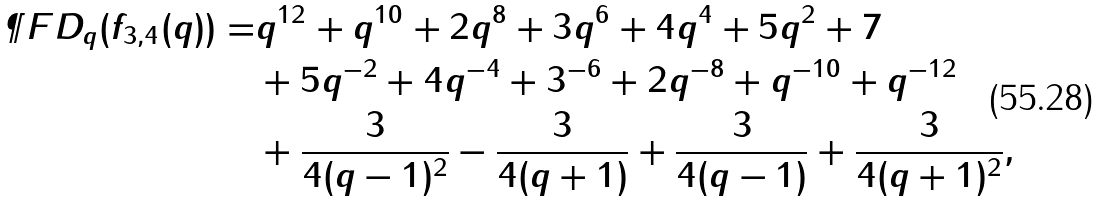Convert formula to latex. <formula><loc_0><loc_0><loc_500><loc_500>\P F D _ { q } ( f _ { 3 , 4 } ( q ) ) = & q ^ { 1 2 } + q ^ { 1 0 } + 2 q ^ { 8 } + 3 q ^ { 6 } + 4 q ^ { 4 } + 5 q ^ { 2 } + 7 \\ & + 5 q ^ { - 2 } + 4 q ^ { - 4 } + 3 ^ { - 6 } + 2 q ^ { - 8 } + q ^ { - 1 0 } + q ^ { - 1 2 } \\ & + \frac { 3 } { 4 ( q - 1 ) ^ { 2 } } - \frac { 3 } { 4 ( q + 1 ) } + \frac { 3 } { 4 ( q - 1 ) } + \frac { 3 } { 4 ( q + 1 ) ^ { 2 } } ,</formula> 